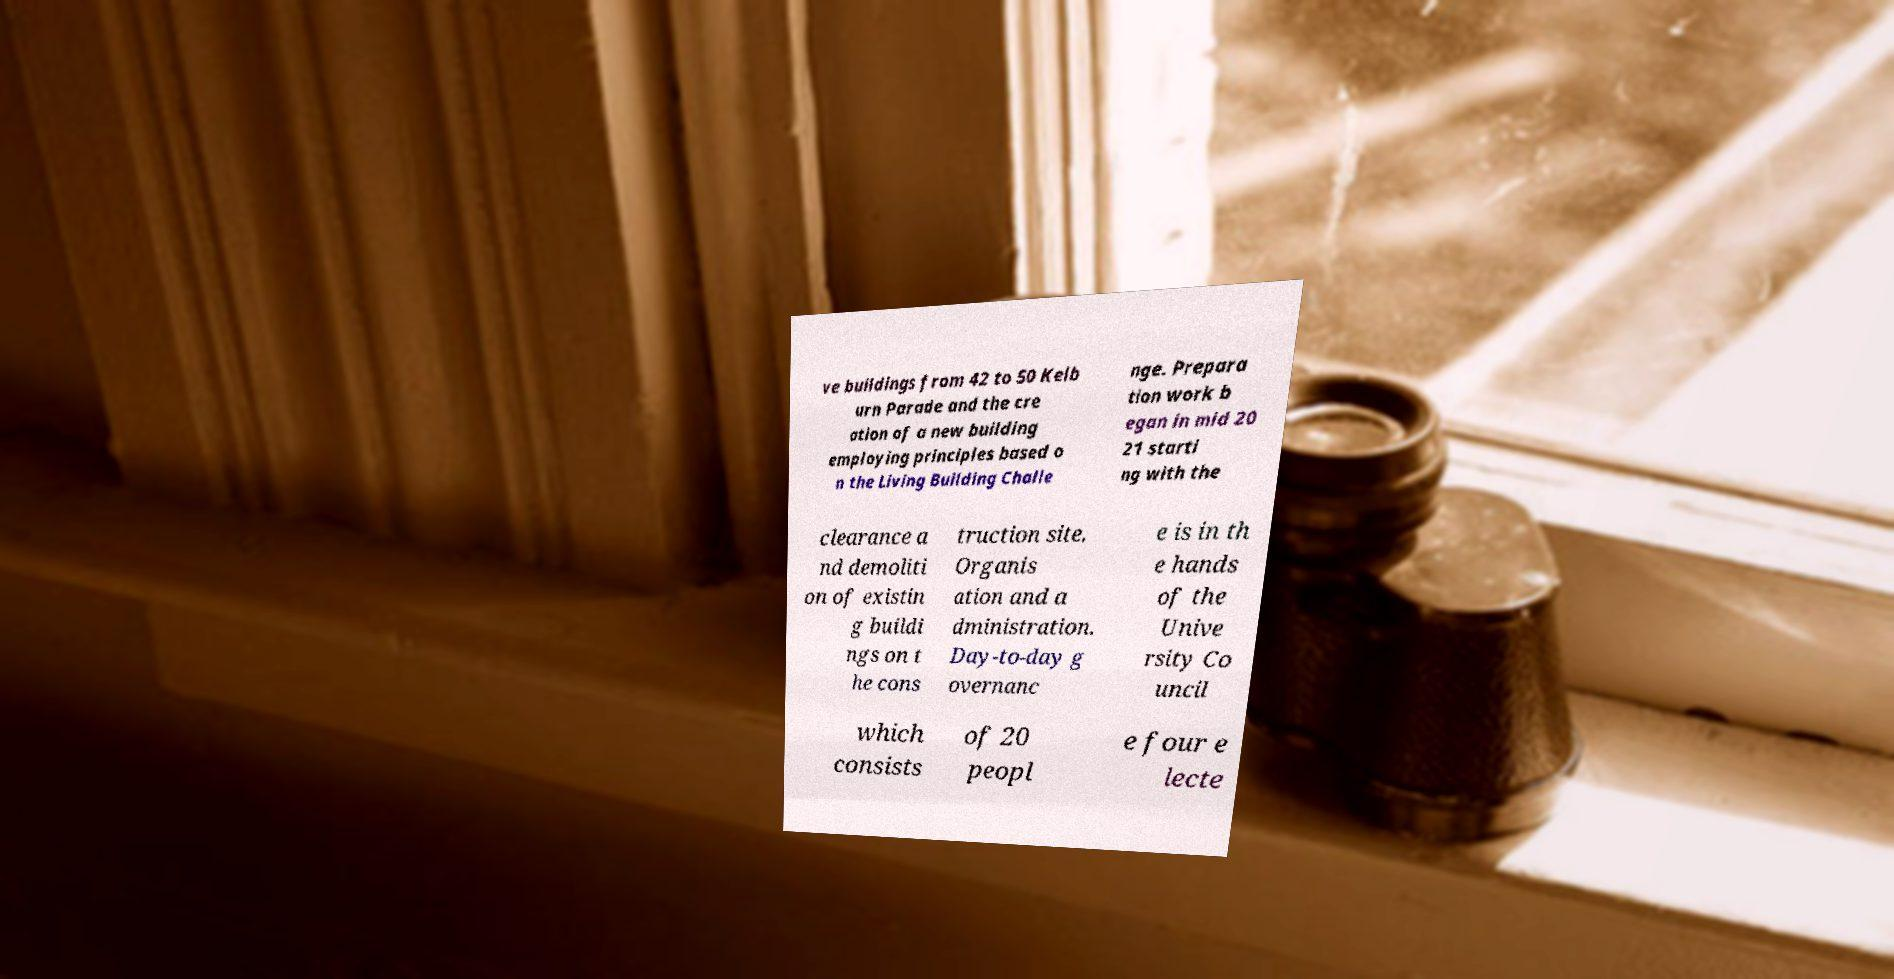There's text embedded in this image that I need extracted. Can you transcribe it verbatim? ve buildings from 42 to 50 Kelb urn Parade and the cre ation of a new building employing principles based o n the Living Building Challe nge. Prepara tion work b egan in mid 20 21 starti ng with the clearance a nd demoliti on of existin g buildi ngs on t he cons truction site. Organis ation and a dministration. Day-to-day g overnanc e is in th e hands of the Unive rsity Co uncil which consists of 20 peopl e four e lecte 